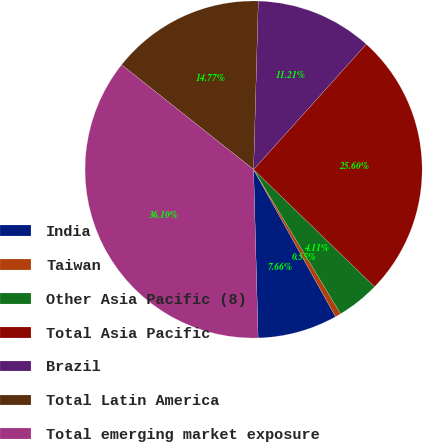Convert chart. <chart><loc_0><loc_0><loc_500><loc_500><pie_chart><fcel>India<fcel>Taiwan<fcel>Other Asia Pacific (8)<fcel>Total Asia Pacific<fcel>Brazil<fcel>Total Latin America<fcel>Total emerging market exposure<nl><fcel>7.66%<fcel>0.55%<fcel>4.11%<fcel>25.6%<fcel>11.21%<fcel>14.77%<fcel>36.1%<nl></chart> 